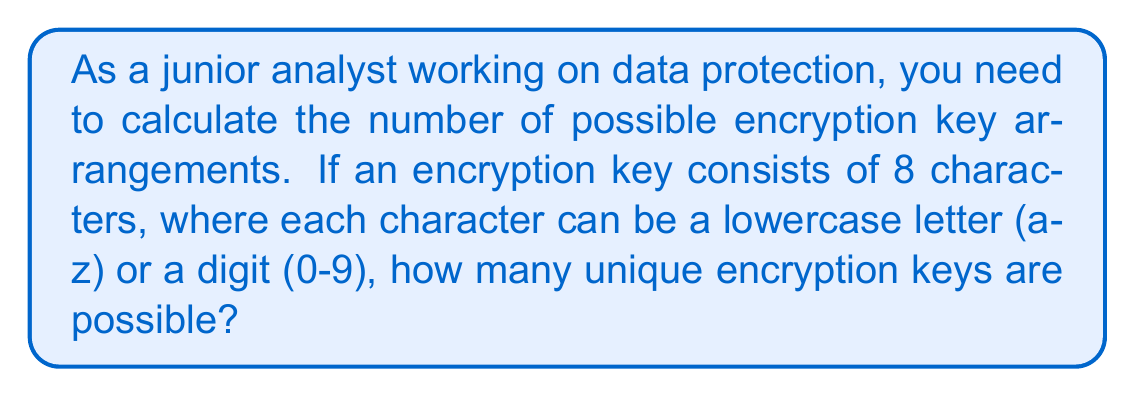Give your solution to this math problem. Let's approach this step-by-step:

1) First, we need to determine how many choices we have for each character:
   - 26 lowercase letters (a-z)
   - 10 digits (0-9)
   Total choices per character: 26 + 10 = 36

2) Now, we need to consider how many characters are in the key:
   - The key consists of 8 characters

3) For each of these 8 positions, we have 36 choices, and the choices are independent of each other.

4) This scenario follows the multiplication principle of counting. When we have a sequence of $n$ independent choices, where each choice has $m$ options, the total number of possibilities is $m^n$.

5) In this case:
   - $m = 36$ (choices per character)
   - $n = 8$ (number of characters in the key)

6) Therefore, the total number of possible encryption keys is:

   $$36^8 = 2,821,109,907,456$$

This large number underscores the importance of using complex encryption keys for data protection.
Answer: $36^8 = 2,821,109,907,456$ 